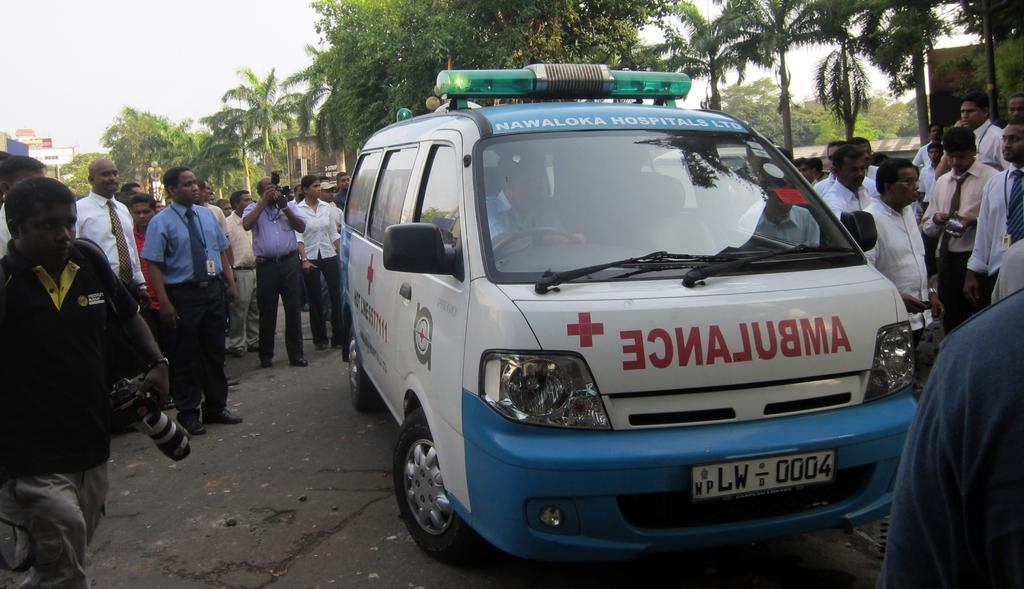In one or two sentences, can you explain what this image depicts? In this Image I see a van and number of people surrounded by it and I can see these are holding the cameras. In the background I see the trees and few buildings. 